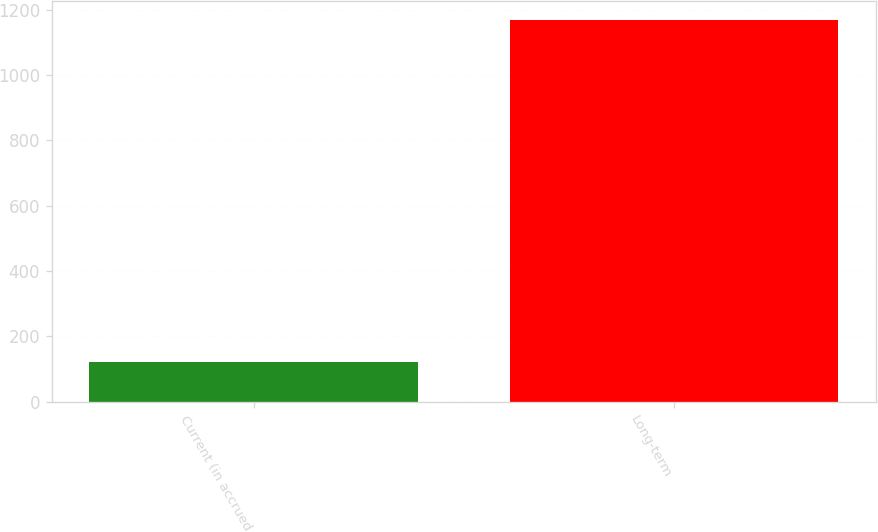Convert chart to OTSL. <chart><loc_0><loc_0><loc_500><loc_500><bar_chart><fcel>Current (in accrued<fcel>Long-term<nl><fcel>123<fcel>1169<nl></chart> 